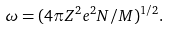Convert formula to latex. <formula><loc_0><loc_0><loc_500><loc_500>\omega = ( 4 \pi Z ^ { 2 } e ^ { 2 } N / M ) ^ { 1 / 2 } .</formula> 